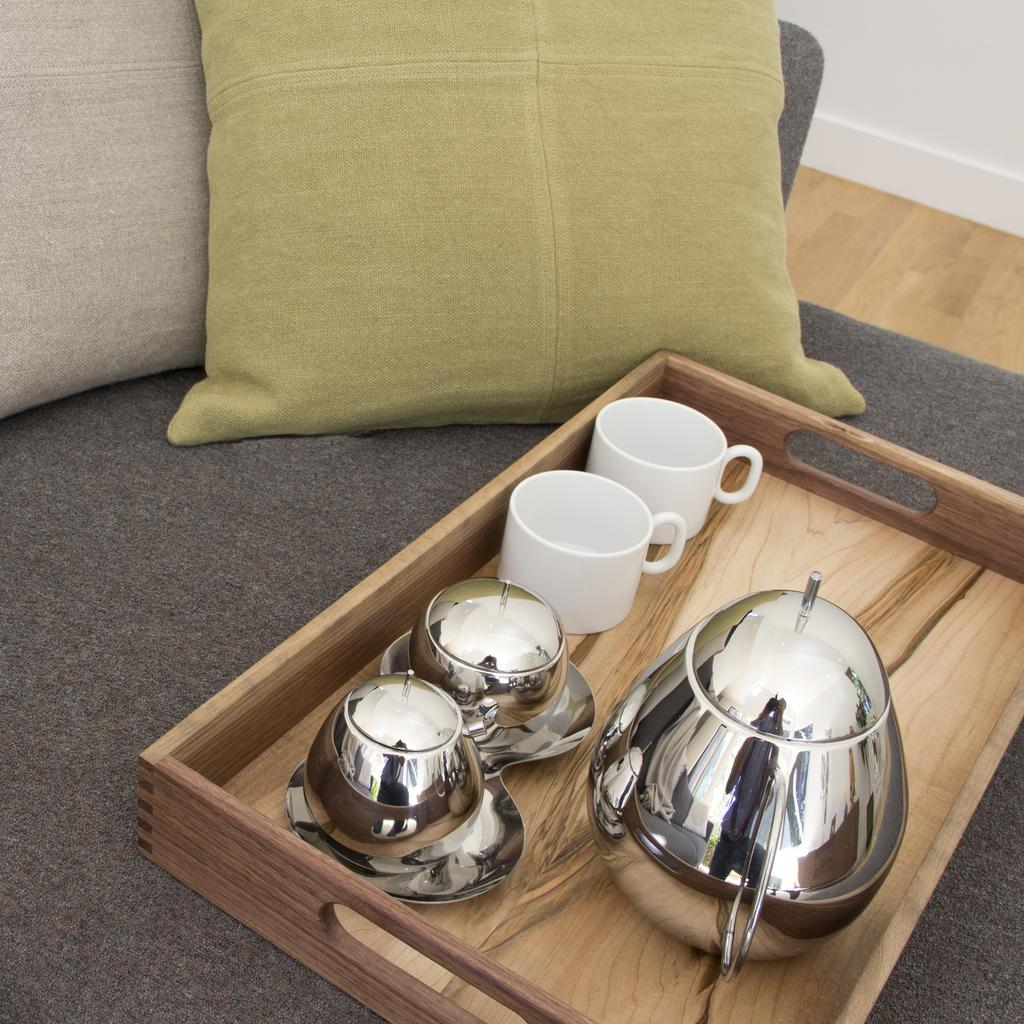What is the main object on the wooden tray in the image? There are two glass cups and two silver cups on the tray in the image. What other objects are visible in the image? There is a pot and a pillow behind the tray in the image. How many cups are on the tray in total? There are four cups on the tray in total, two glass cups and two silver cups. What type of soap is being used to write a letter on the pillow in the image? There is no soap or letter present in the image; it only features a wooden tray with cups, a pot, and a pillow. 